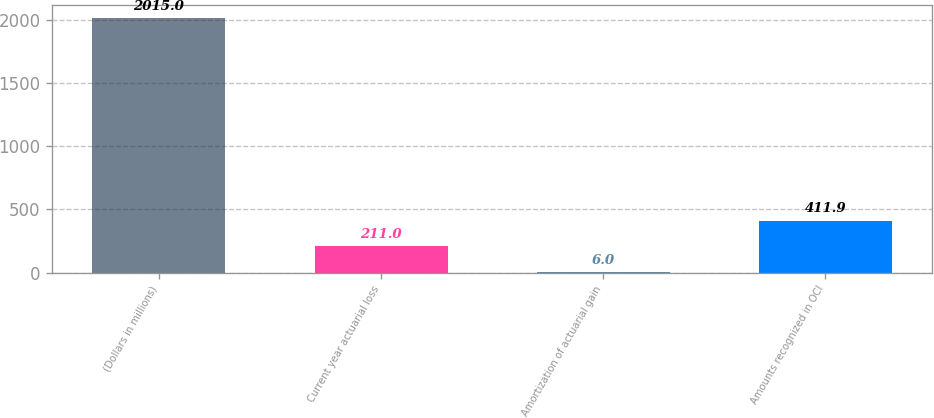<chart> <loc_0><loc_0><loc_500><loc_500><bar_chart><fcel>(Dollars in millions)<fcel>Current year actuarial loss<fcel>Amortization of actuarial gain<fcel>Amounts recognized in OCI<nl><fcel>2015<fcel>211<fcel>6<fcel>411.9<nl></chart> 